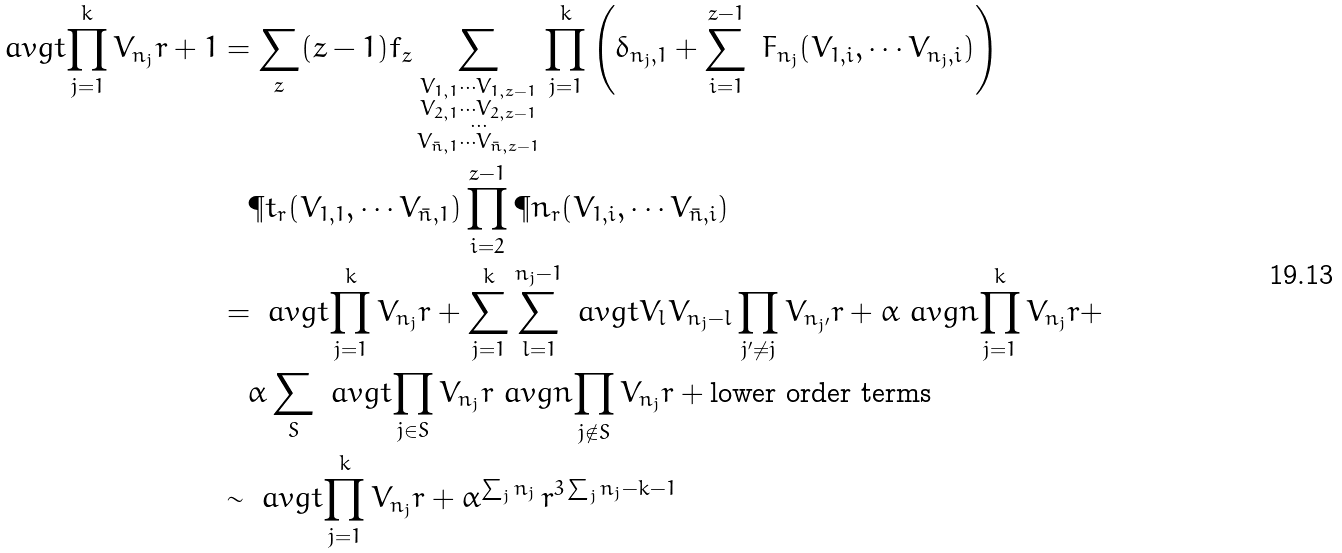Convert formula to latex. <formula><loc_0><loc_0><loc_500><loc_500>\ a v g t { \prod _ { j = 1 } ^ { k } V _ { n _ { j } } } { r + 1 } & = \sum _ { z } ( z - 1 ) f _ { z } \sum _ { \substack { V _ { 1 , 1 } \cdots V _ { 1 , z - 1 } \\ V _ { 2 , 1 } \cdots V _ { 2 , z - 1 } \\ \cdots \\ V _ { \bar { n } , 1 } \cdots V _ { \bar { n } , z - 1 } } } \prod _ { j = 1 } ^ { k } \left ( \delta _ { n _ { j } , 1 } + \sum _ { i = 1 } ^ { z - 1 } \ F _ { n _ { j } } ( V _ { 1 , i } , \cdots V _ { n _ { j } , i } ) \right ) \\ & \quad \P t _ { r } ( V _ { 1 , 1 } , \cdots V _ { \bar { n } , 1 } ) \prod _ { i = 2 } ^ { z - 1 } \P n _ { r } ( V _ { 1 , i } , \cdots V _ { \bar { n } , i } ) \\ & = \ a v g t { \prod _ { j = 1 } ^ { k } V _ { n _ { j } } } { r } + \sum _ { j = 1 } ^ { k } \sum _ { l = 1 } ^ { n _ { j } - 1 } \ a v g t { V _ { l } V _ { n _ { j } - l } \prod _ { j ^ { \prime } \ne j } V _ { n _ { j ^ { \prime } } } } { r } + \alpha \ a v g n { \prod _ { j = 1 } ^ { k } V _ { n _ { j } } } { r } + \\ & \quad \alpha \sum _ { S } \ a v g t { \prod _ { j \in S } V _ { n _ { j } } } { r } \ a v g n { \prod _ { j \notin S } V _ { n _ { j } } } { r } + \text {lower order terms} \\ & \sim \ a v g t { \prod _ { j = 1 } ^ { k } V _ { n _ { j } } } { r } + \alpha ^ { \sum _ { j } n _ { j } } \, r ^ { 3 \sum _ { j } n _ { j } - k - 1 }</formula> 